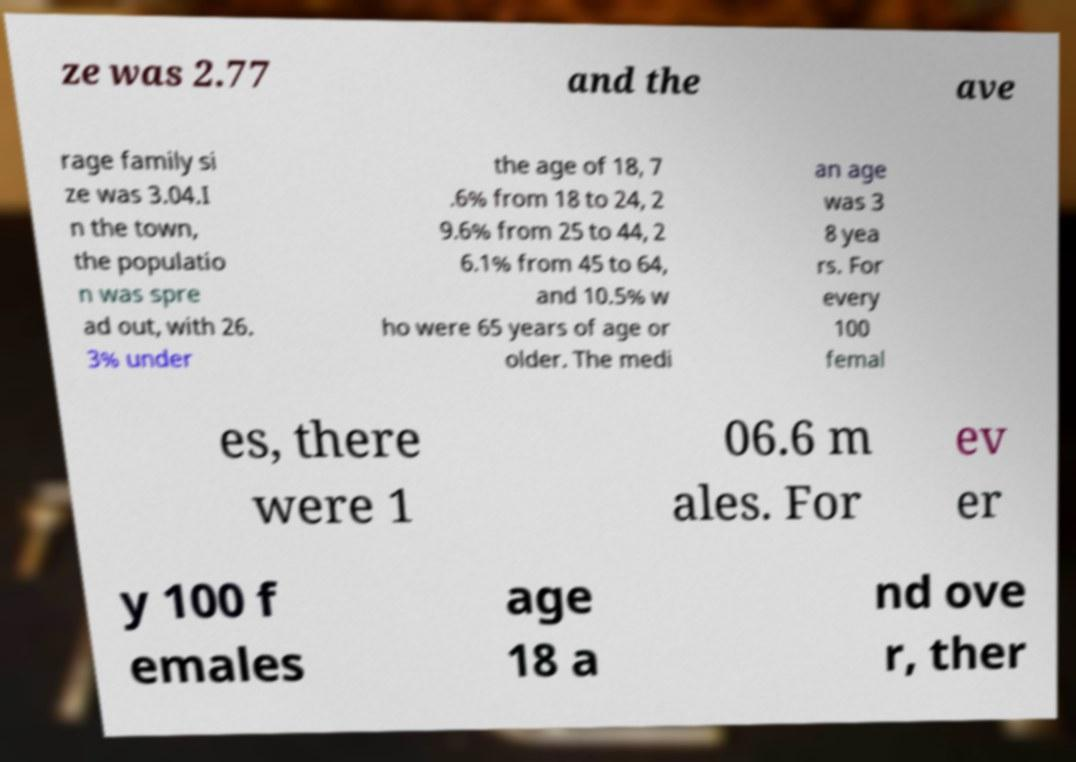What messages or text are displayed in this image? I need them in a readable, typed format. ze was 2.77 and the ave rage family si ze was 3.04.I n the town, the populatio n was spre ad out, with 26. 3% under the age of 18, 7 .6% from 18 to 24, 2 9.6% from 25 to 44, 2 6.1% from 45 to 64, and 10.5% w ho were 65 years of age or older. The medi an age was 3 8 yea rs. For every 100 femal es, there were 1 06.6 m ales. For ev er y 100 f emales age 18 a nd ove r, ther 